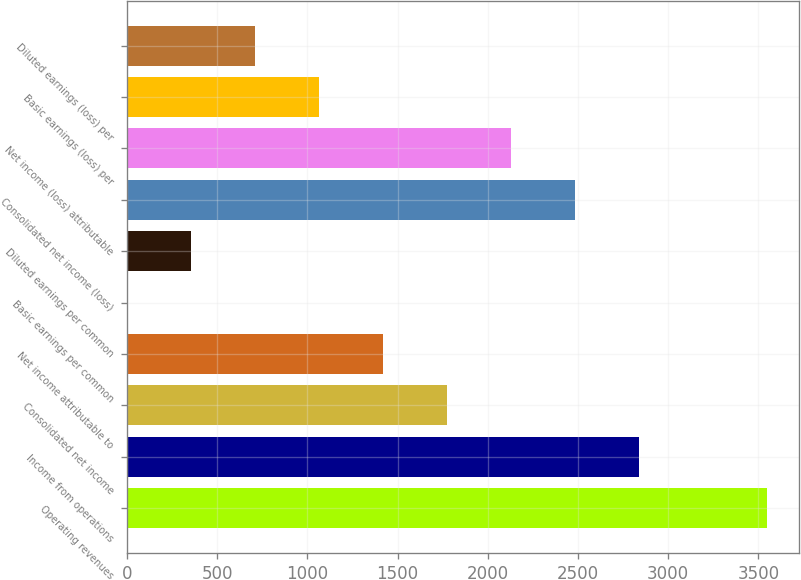Convert chart to OTSL. <chart><loc_0><loc_0><loc_500><loc_500><bar_chart><fcel>Operating revenues<fcel>Income from operations<fcel>Consolidated net income<fcel>Net income attributable to<fcel>Basic earnings per common<fcel>Diluted earnings per common<fcel>Consolidated net income (loss)<fcel>Net income (loss) attributable<fcel>Basic earnings (loss) per<fcel>Diluted earnings (loss) per<nl><fcel>3548<fcel>2838.52<fcel>1774.33<fcel>1419.6<fcel>0.68<fcel>355.41<fcel>2483.79<fcel>2129.06<fcel>1064.87<fcel>710.14<nl></chart> 